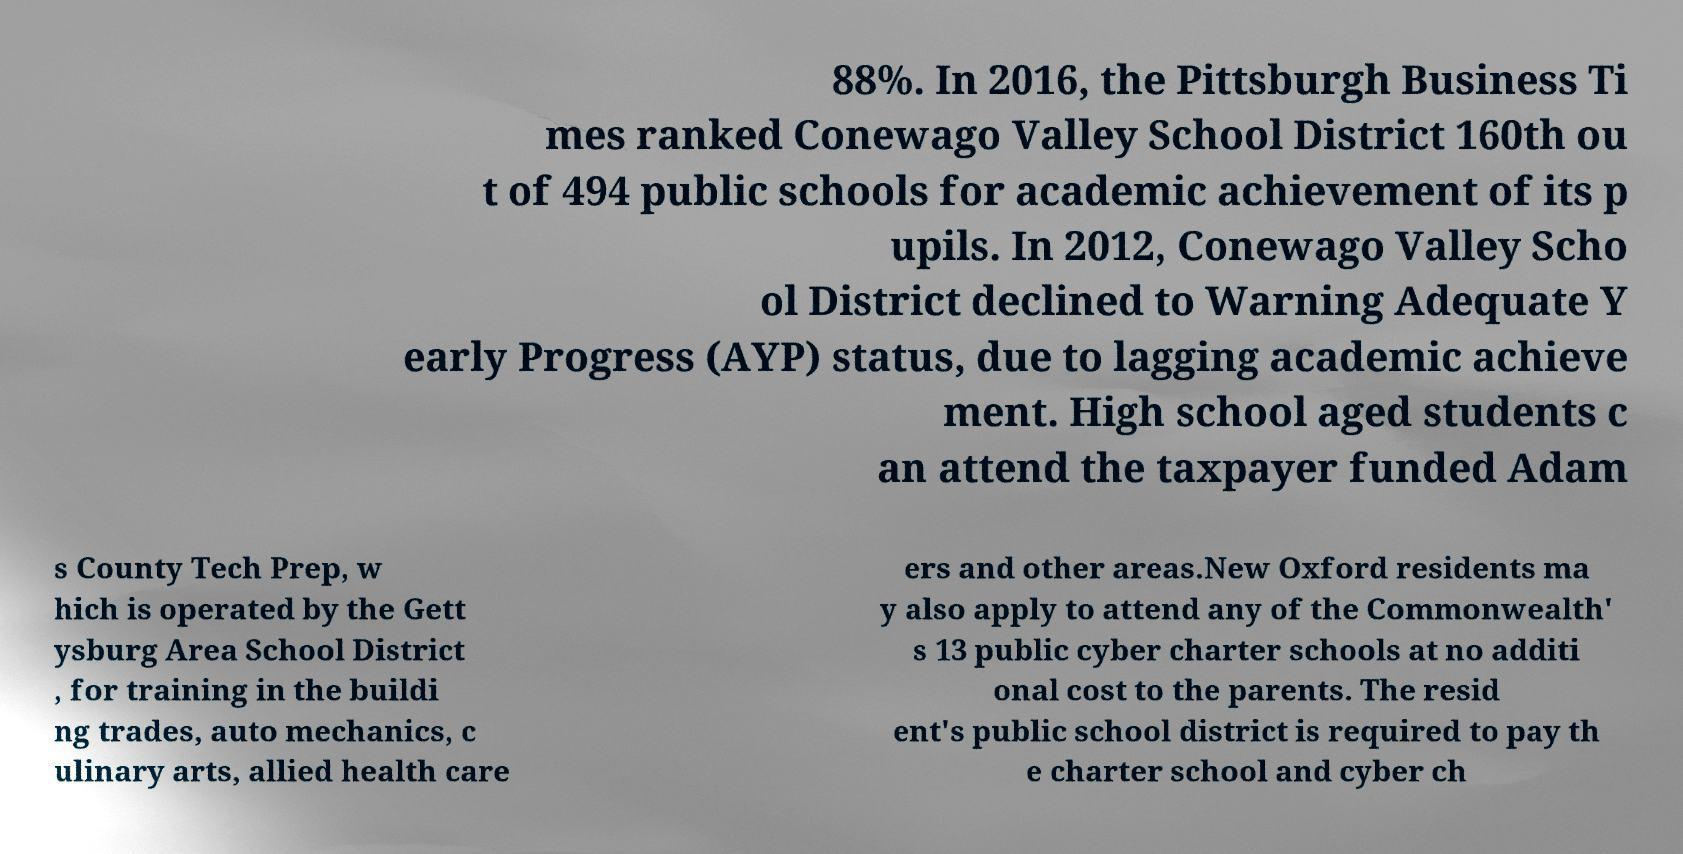Can you accurately transcribe the text from the provided image for me? 88%. In 2016, the Pittsburgh Business Ti mes ranked Conewago Valley School District 160th ou t of 494 public schools for academic achievement of its p upils. In 2012, Conewago Valley Scho ol District declined to Warning Adequate Y early Progress (AYP) status, due to lagging academic achieve ment. High school aged students c an attend the taxpayer funded Adam s County Tech Prep, w hich is operated by the Gett ysburg Area School District , for training in the buildi ng trades, auto mechanics, c ulinary arts, allied health care ers and other areas.New Oxford residents ma y also apply to attend any of the Commonwealth' s 13 public cyber charter schools at no additi onal cost to the parents. The resid ent's public school district is required to pay th e charter school and cyber ch 